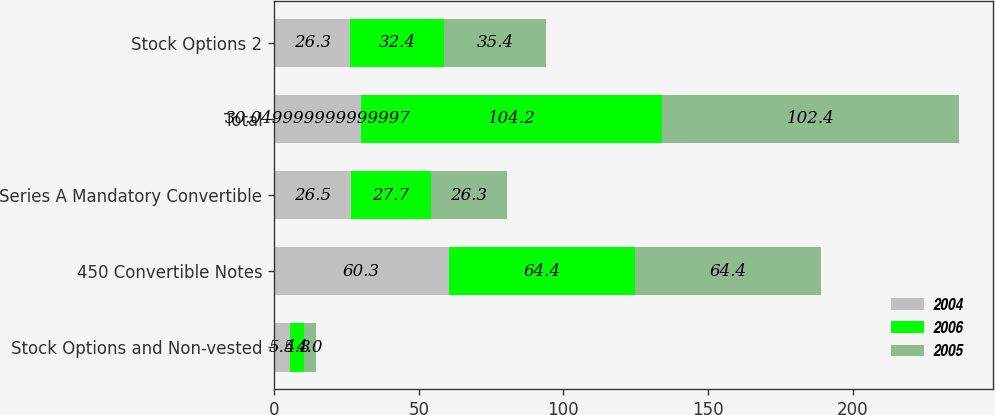<chart> <loc_0><loc_0><loc_500><loc_500><stacked_bar_chart><ecel><fcel>Stock Options and Non-vested<fcel>450 Convertible Notes<fcel>Series A Mandatory Convertible<fcel>Total<fcel>Stock Options 2<nl><fcel>2004<fcel>5.5<fcel>60.3<fcel>26.5<fcel>30.05<fcel>26.3<nl><fcel>2006<fcel>4.8<fcel>64.4<fcel>27.7<fcel>104.2<fcel>32.4<nl><fcel>2005<fcel>4<fcel>64.4<fcel>26.3<fcel>102.4<fcel>35.4<nl></chart> 